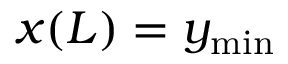<formula> <loc_0><loc_0><loc_500><loc_500>x ( L ) = y _ { \min }</formula> 